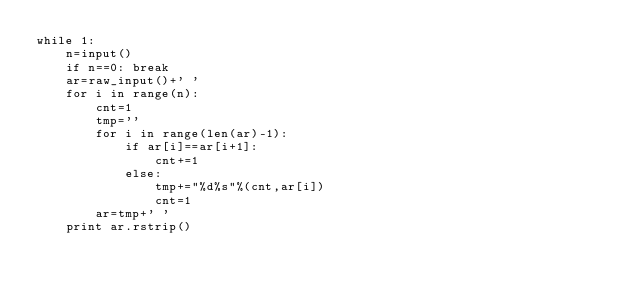Convert code to text. <code><loc_0><loc_0><loc_500><loc_500><_Python_>while 1:
    n=input()
    if n==0: break
    ar=raw_input()+' '
    for i in range(n):
        cnt=1
        tmp=''
        for i in range(len(ar)-1):
            if ar[i]==ar[i+1]:
                cnt+=1
            else:
                tmp+="%d%s"%(cnt,ar[i])
                cnt=1
        ar=tmp+' '
    print ar.rstrip()</code> 